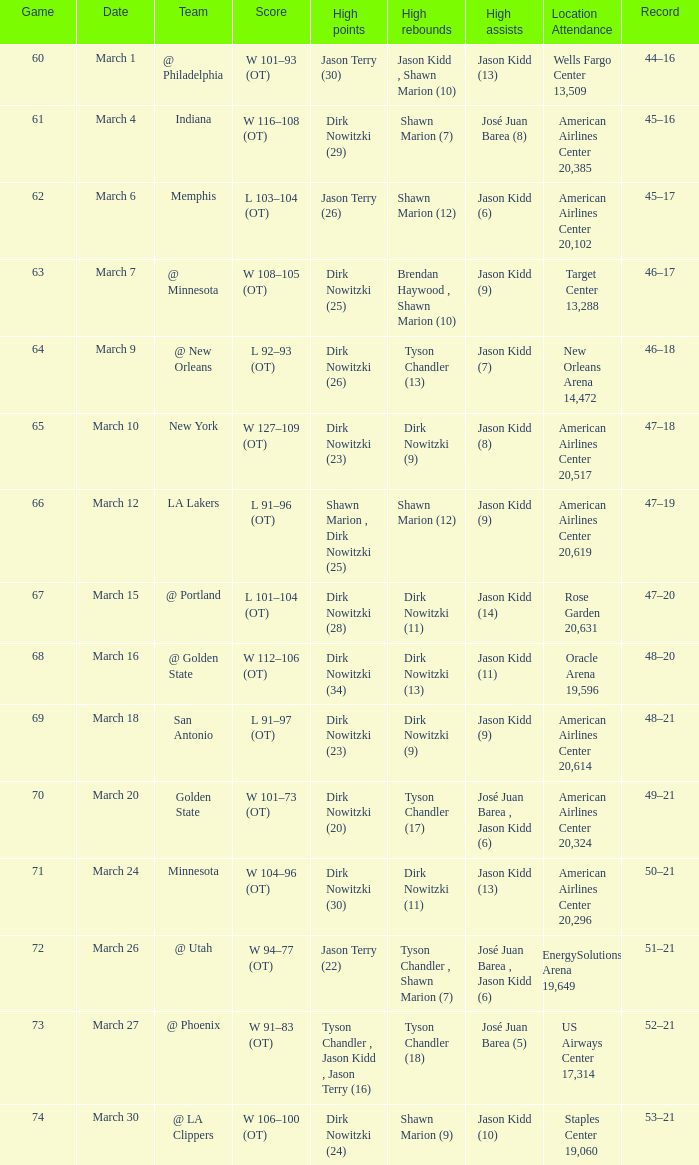Name the high points for march 30 Dirk Nowitzki (24). 